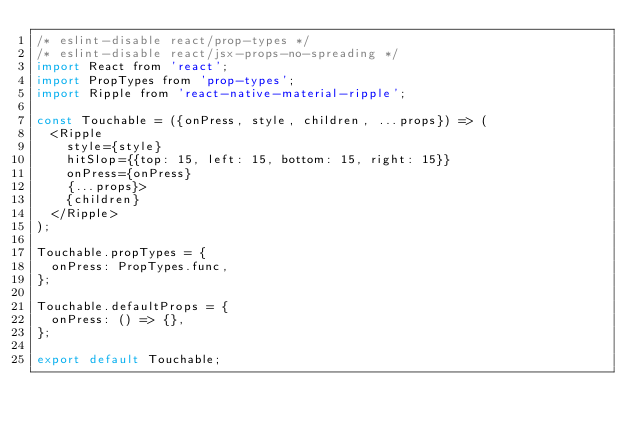<code> <loc_0><loc_0><loc_500><loc_500><_JavaScript_>/* eslint-disable react/prop-types */
/* eslint-disable react/jsx-props-no-spreading */
import React from 'react';
import PropTypes from 'prop-types';
import Ripple from 'react-native-material-ripple';

const Touchable = ({onPress, style, children, ...props}) => (
  <Ripple
    style={style}
    hitSlop={{top: 15, left: 15, bottom: 15, right: 15}}
    onPress={onPress}
    {...props}>
    {children}
  </Ripple>
);

Touchable.propTypes = {
  onPress: PropTypes.func,
};

Touchable.defaultProps = {
  onPress: () => {},
};

export default Touchable;
</code> 